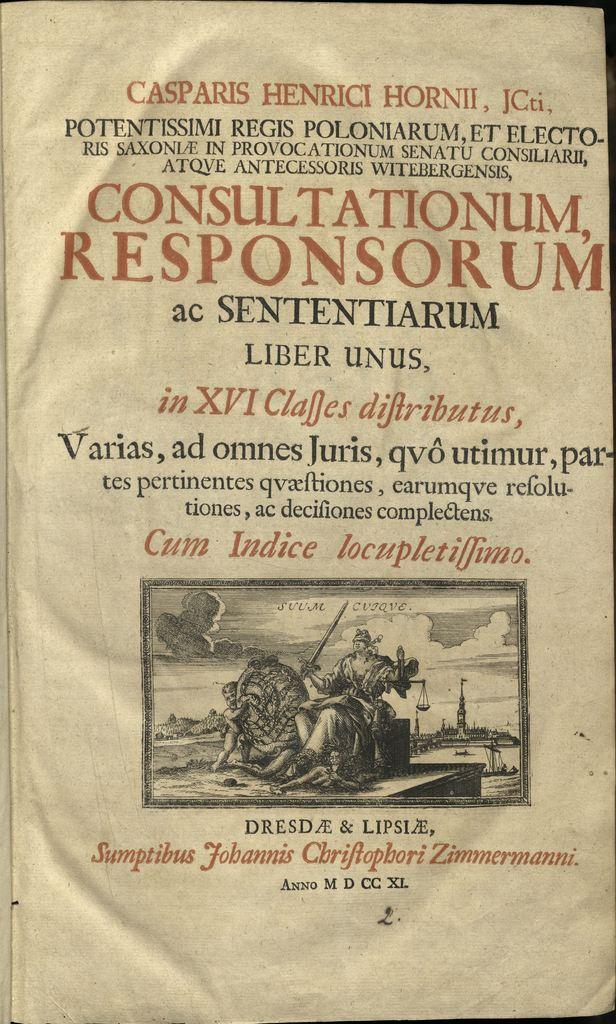What is the year (anno) at the bottom, in letters?
Make the answer very short. M d cc xl. 